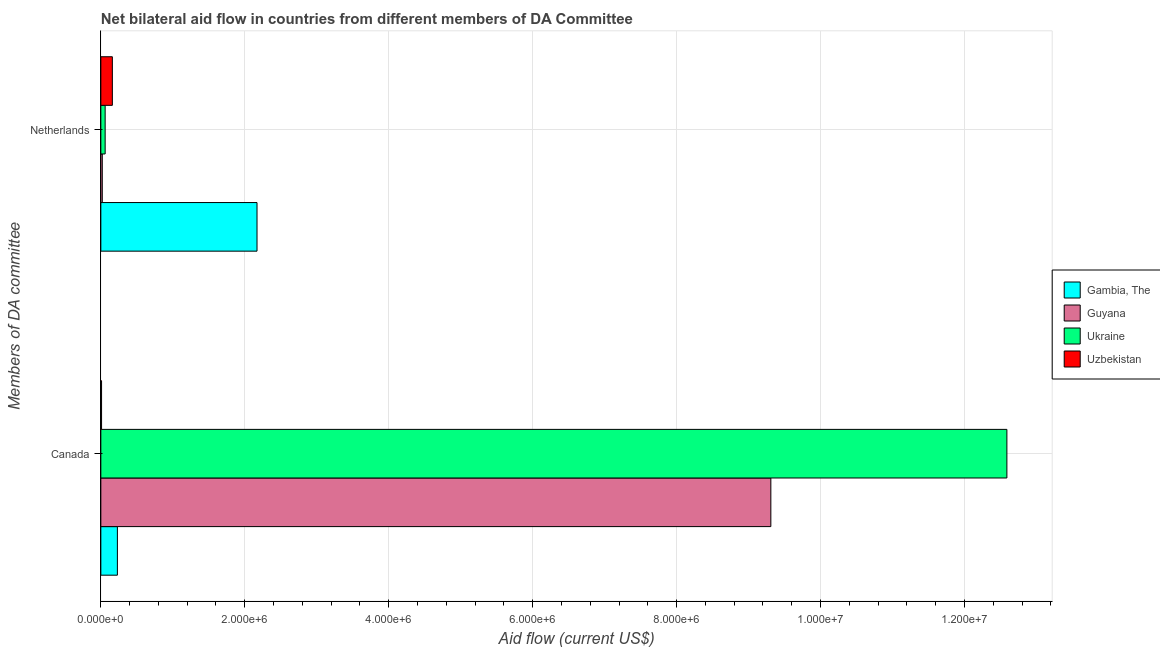How many different coloured bars are there?
Make the answer very short. 4. Are the number of bars per tick equal to the number of legend labels?
Provide a short and direct response. Yes. How many bars are there on the 1st tick from the top?
Your answer should be very brief. 4. What is the label of the 2nd group of bars from the top?
Give a very brief answer. Canada. What is the amount of aid given by netherlands in Gambia, The?
Ensure brevity in your answer.  2.17e+06. Across all countries, what is the maximum amount of aid given by canada?
Ensure brevity in your answer.  1.26e+07. Across all countries, what is the minimum amount of aid given by netherlands?
Offer a terse response. 2.00e+04. In which country was the amount of aid given by netherlands maximum?
Provide a short and direct response. Gambia, The. In which country was the amount of aid given by canada minimum?
Provide a succinct answer. Uzbekistan. What is the total amount of aid given by netherlands in the graph?
Your answer should be very brief. 2.41e+06. What is the difference between the amount of aid given by canada in Guyana and that in Uzbekistan?
Ensure brevity in your answer.  9.30e+06. What is the difference between the amount of aid given by canada in Uzbekistan and the amount of aid given by netherlands in Guyana?
Make the answer very short. -10000. What is the average amount of aid given by canada per country?
Give a very brief answer. 5.54e+06. What is the difference between the amount of aid given by canada and amount of aid given by netherlands in Guyana?
Offer a very short reply. 9.29e+06. What is the ratio of the amount of aid given by canada in Guyana to that in Ukraine?
Provide a short and direct response. 0.74. Is the amount of aid given by canada in Gambia, The less than that in Uzbekistan?
Offer a very short reply. No. In how many countries, is the amount of aid given by netherlands greater than the average amount of aid given by netherlands taken over all countries?
Make the answer very short. 1. What does the 1st bar from the top in Netherlands represents?
Your answer should be compact. Uzbekistan. What does the 1st bar from the bottom in Canada represents?
Your answer should be compact. Gambia, The. Are all the bars in the graph horizontal?
Provide a short and direct response. Yes. Are the values on the major ticks of X-axis written in scientific E-notation?
Ensure brevity in your answer.  Yes. Does the graph contain any zero values?
Ensure brevity in your answer.  No. Does the graph contain grids?
Ensure brevity in your answer.  Yes. Where does the legend appear in the graph?
Offer a very short reply. Center right. How many legend labels are there?
Provide a succinct answer. 4. How are the legend labels stacked?
Provide a short and direct response. Vertical. What is the title of the graph?
Offer a very short reply. Net bilateral aid flow in countries from different members of DA Committee. Does "Jamaica" appear as one of the legend labels in the graph?
Provide a short and direct response. No. What is the label or title of the X-axis?
Make the answer very short. Aid flow (current US$). What is the label or title of the Y-axis?
Ensure brevity in your answer.  Members of DA committee. What is the Aid flow (current US$) in Gambia, The in Canada?
Give a very brief answer. 2.30e+05. What is the Aid flow (current US$) of Guyana in Canada?
Your response must be concise. 9.31e+06. What is the Aid flow (current US$) in Ukraine in Canada?
Keep it short and to the point. 1.26e+07. What is the Aid flow (current US$) in Gambia, The in Netherlands?
Keep it short and to the point. 2.17e+06. What is the Aid flow (current US$) of Uzbekistan in Netherlands?
Provide a short and direct response. 1.60e+05. Across all Members of DA committee, what is the maximum Aid flow (current US$) of Gambia, The?
Your answer should be very brief. 2.17e+06. Across all Members of DA committee, what is the maximum Aid flow (current US$) in Guyana?
Your answer should be compact. 9.31e+06. Across all Members of DA committee, what is the maximum Aid flow (current US$) of Ukraine?
Keep it short and to the point. 1.26e+07. Across all Members of DA committee, what is the maximum Aid flow (current US$) in Uzbekistan?
Offer a terse response. 1.60e+05. What is the total Aid flow (current US$) in Gambia, The in the graph?
Ensure brevity in your answer.  2.40e+06. What is the total Aid flow (current US$) of Guyana in the graph?
Offer a terse response. 9.33e+06. What is the total Aid flow (current US$) in Ukraine in the graph?
Offer a very short reply. 1.26e+07. What is the total Aid flow (current US$) in Uzbekistan in the graph?
Give a very brief answer. 1.70e+05. What is the difference between the Aid flow (current US$) in Gambia, The in Canada and that in Netherlands?
Provide a succinct answer. -1.94e+06. What is the difference between the Aid flow (current US$) of Guyana in Canada and that in Netherlands?
Offer a terse response. 9.29e+06. What is the difference between the Aid flow (current US$) in Ukraine in Canada and that in Netherlands?
Provide a succinct answer. 1.25e+07. What is the difference between the Aid flow (current US$) of Gambia, The in Canada and the Aid flow (current US$) of Guyana in Netherlands?
Make the answer very short. 2.10e+05. What is the difference between the Aid flow (current US$) of Gambia, The in Canada and the Aid flow (current US$) of Ukraine in Netherlands?
Offer a very short reply. 1.70e+05. What is the difference between the Aid flow (current US$) of Guyana in Canada and the Aid flow (current US$) of Ukraine in Netherlands?
Your answer should be compact. 9.25e+06. What is the difference between the Aid flow (current US$) of Guyana in Canada and the Aid flow (current US$) of Uzbekistan in Netherlands?
Your response must be concise. 9.15e+06. What is the difference between the Aid flow (current US$) of Ukraine in Canada and the Aid flow (current US$) of Uzbekistan in Netherlands?
Offer a very short reply. 1.24e+07. What is the average Aid flow (current US$) in Gambia, The per Members of DA committee?
Your answer should be compact. 1.20e+06. What is the average Aid flow (current US$) of Guyana per Members of DA committee?
Offer a terse response. 4.66e+06. What is the average Aid flow (current US$) of Ukraine per Members of DA committee?
Make the answer very short. 6.32e+06. What is the average Aid flow (current US$) in Uzbekistan per Members of DA committee?
Ensure brevity in your answer.  8.50e+04. What is the difference between the Aid flow (current US$) in Gambia, The and Aid flow (current US$) in Guyana in Canada?
Offer a terse response. -9.08e+06. What is the difference between the Aid flow (current US$) of Gambia, The and Aid flow (current US$) of Ukraine in Canada?
Your answer should be compact. -1.24e+07. What is the difference between the Aid flow (current US$) of Gambia, The and Aid flow (current US$) of Uzbekistan in Canada?
Keep it short and to the point. 2.20e+05. What is the difference between the Aid flow (current US$) of Guyana and Aid flow (current US$) of Ukraine in Canada?
Your answer should be compact. -3.28e+06. What is the difference between the Aid flow (current US$) of Guyana and Aid flow (current US$) of Uzbekistan in Canada?
Keep it short and to the point. 9.30e+06. What is the difference between the Aid flow (current US$) in Ukraine and Aid flow (current US$) in Uzbekistan in Canada?
Your answer should be very brief. 1.26e+07. What is the difference between the Aid flow (current US$) of Gambia, The and Aid flow (current US$) of Guyana in Netherlands?
Make the answer very short. 2.15e+06. What is the difference between the Aid flow (current US$) in Gambia, The and Aid flow (current US$) in Ukraine in Netherlands?
Offer a terse response. 2.11e+06. What is the difference between the Aid flow (current US$) of Gambia, The and Aid flow (current US$) of Uzbekistan in Netherlands?
Your response must be concise. 2.01e+06. What is the difference between the Aid flow (current US$) of Ukraine and Aid flow (current US$) of Uzbekistan in Netherlands?
Your answer should be very brief. -1.00e+05. What is the ratio of the Aid flow (current US$) of Gambia, The in Canada to that in Netherlands?
Ensure brevity in your answer.  0.11. What is the ratio of the Aid flow (current US$) in Guyana in Canada to that in Netherlands?
Keep it short and to the point. 465.5. What is the ratio of the Aid flow (current US$) in Ukraine in Canada to that in Netherlands?
Provide a succinct answer. 209.83. What is the ratio of the Aid flow (current US$) of Uzbekistan in Canada to that in Netherlands?
Make the answer very short. 0.06. What is the difference between the highest and the second highest Aid flow (current US$) in Gambia, The?
Your response must be concise. 1.94e+06. What is the difference between the highest and the second highest Aid flow (current US$) of Guyana?
Give a very brief answer. 9.29e+06. What is the difference between the highest and the second highest Aid flow (current US$) of Ukraine?
Keep it short and to the point. 1.25e+07. What is the difference between the highest and the lowest Aid flow (current US$) of Gambia, The?
Make the answer very short. 1.94e+06. What is the difference between the highest and the lowest Aid flow (current US$) of Guyana?
Offer a terse response. 9.29e+06. What is the difference between the highest and the lowest Aid flow (current US$) of Ukraine?
Ensure brevity in your answer.  1.25e+07. 